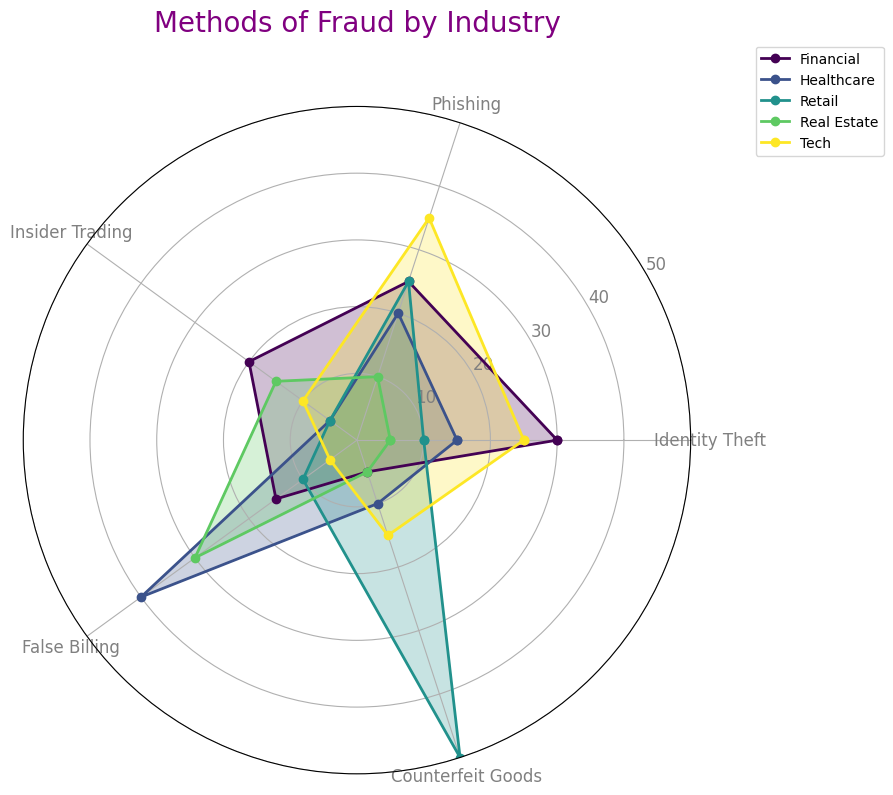What industry has the highest value for Phishing? In the radar chart, look for the peak values along the Phishing axis for each industry. Tech peaks higher than others at a value of 35.
Answer: Tech Which industries have a value of 10 for Counterfeit Goods? Check the Counterfeit Goods axis and identify the industries that reach the value of 10. Healthcare and Tech both reach 10.
Answer: Healthcare and Tech How does Identity Theft in Retail compare to Financial? Compare the values for Identity Theft for Retail and Financial by looking at their respective positions on the Identity Theft axis. Financial is 30, and Retail is 10, so Financial is higher.
Answer: Financial is higher What's the average value of False Billing across all industries? Sum the values for False Billing across all industries and then divide by the number of industries: (15 + 40 + 10 + 30 + 5) / 5 = 20
Answer: 20 If you sum the values of Insider Trading and False Billing in Tech, what is the result? Add the values of Insider Trading and False Billing specifically for Tech: 10 + 5 = 15
Answer: 15 What is the combined value of Phishing and Identity Theft in Healthcare? Sum the values of Phishing and Identity Theft in Healthcare: 20 + 15 = 35
Answer: 35 Which industry shows the highest value for Counterfeit Goods, and what is that value? Check the Counterfeit Goods axis and identify the industry with the maximum value. Retail has the highest value of 50.
Answer: Retail, 50 Between Financial and Real Estate, which industry has a higher average fraud value across all methods? Calculate the average fraud value for each method in Financial and Real Estate, then compare. Financial: (30 + 25 + 20 + 15 + 5) / 5 = 19. Real Estate: (5 + 10 + 15 + 30 + 5) / 5 = 13. Financial is higher.
Answer: Financial 